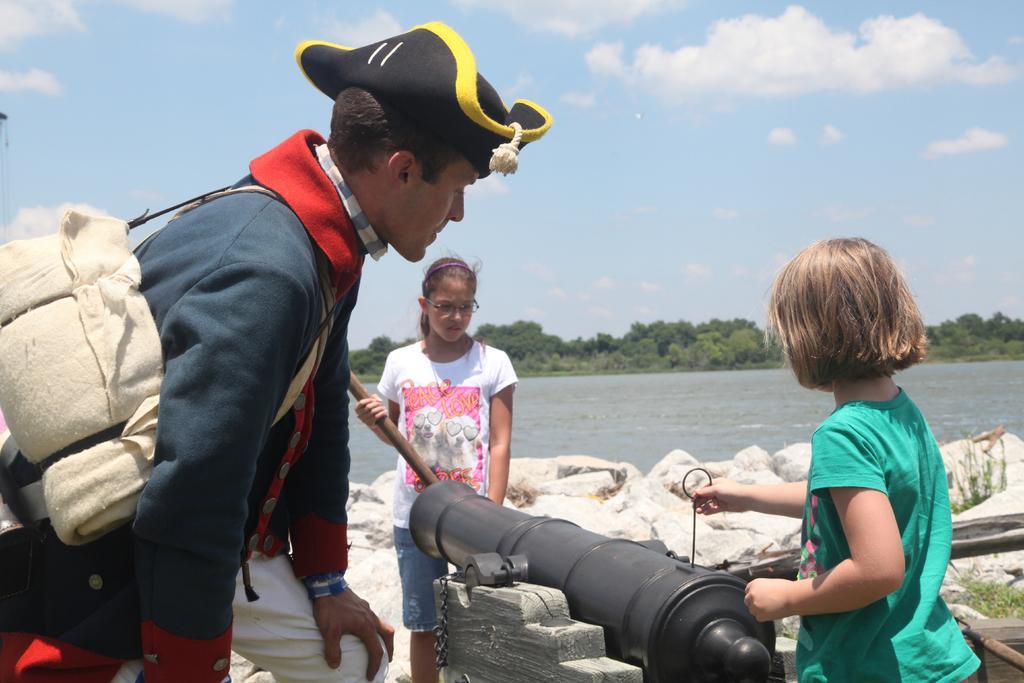In one or two sentences, can you explain what this image depicts? On the left side, there is a person having a handbag on his shoulder and wearing a cap. On the right side, there is a girl in a green color T-shirt, holding a needle of a black color object. In front of this object, there is another girl in a white color, there is water, there are trees and there is sky. 